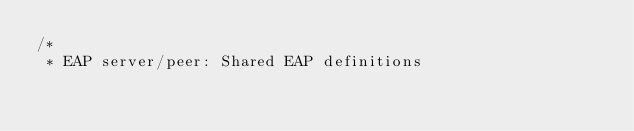Convert code to text. <code><loc_0><loc_0><loc_500><loc_500><_C_>/*
 * EAP server/peer: Shared EAP definitions</code> 